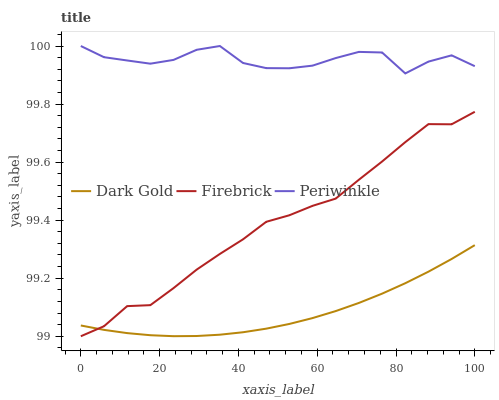Does Dark Gold have the minimum area under the curve?
Answer yes or no. Yes. Does Periwinkle have the maximum area under the curve?
Answer yes or no. Yes. Does Periwinkle have the minimum area under the curve?
Answer yes or no. No. Does Dark Gold have the maximum area under the curve?
Answer yes or no. No. Is Dark Gold the smoothest?
Answer yes or no. Yes. Is Periwinkle the roughest?
Answer yes or no. Yes. Is Periwinkle the smoothest?
Answer yes or no. No. Is Dark Gold the roughest?
Answer yes or no. No. Does Firebrick have the lowest value?
Answer yes or no. Yes. Does Dark Gold have the lowest value?
Answer yes or no. No. Does Periwinkle have the highest value?
Answer yes or no. Yes. Does Dark Gold have the highest value?
Answer yes or no. No. Is Firebrick less than Periwinkle?
Answer yes or no. Yes. Is Periwinkle greater than Firebrick?
Answer yes or no. Yes. Does Dark Gold intersect Firebrick?
Answer yes or no. Yes. Is Dark Gold less than Firebrick?
Answer yes or no. No. Is Dark Gold greater than Firebrick?
Answer yes or no. No. Does Firebrick intersect Periwinkle?
Answer yes or no. No. 